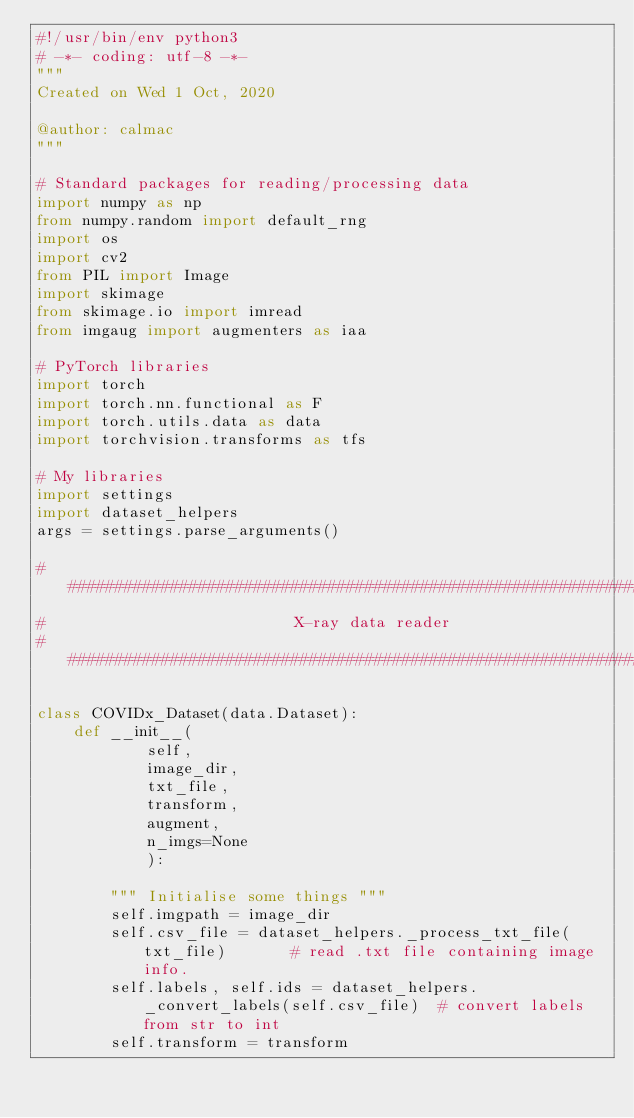<code> <loc_0><loc_0><loc_500><loc_500><_Python_>#!/usr/bin/env python3
# -*- coding: utf-8 -*-
"""
Created on Wed 1 Oct, 2020

@author: calmac
"""

# Standard packages for reading/processing data 
import numpy as np
from numpy.random import default_rng
import os
import cv2
from PIL import Image
import skimage
from skimage.io import imread
from imgaug import augmenters as iaa

# PyTorch libraries
import torch
import torch.nn.functional as F
import torch.utils.data as data
import torchvision.transforms as tfs

# My libraries
import settings
import dataset_helpers
args = settings.parse_arguments()

##########################################################################
#                           X-ray data reader  
##########################################################################

class COVIDx_Dataset(data.Dataset):
    def __init__(
            self,
            image_dir,
            txt_file,
            transform, 
            augment,
            n_imgs=None
            ):
        
        """ Initialise some things """
        self.imgpath = image_dir
        self.csv_file = dataset_helpers._process_txt_file(txt_file)       # read .txt file containing image info.
        self.labels, self.ids = dataset_helpers._convert_labels(self.csv_file)  # convert labels from str to int
        self.transform = transform</code> 